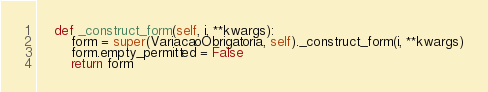<code> <loc_0><loc_0><loc_500><loc_500><_Python_>    def _construct_form(self, i, **kwargs):
        form = super(VariacaoObrigatoria, self)._construct_form(i, **kwargs)
        form.empty_permitted = False
        return form
</code> 